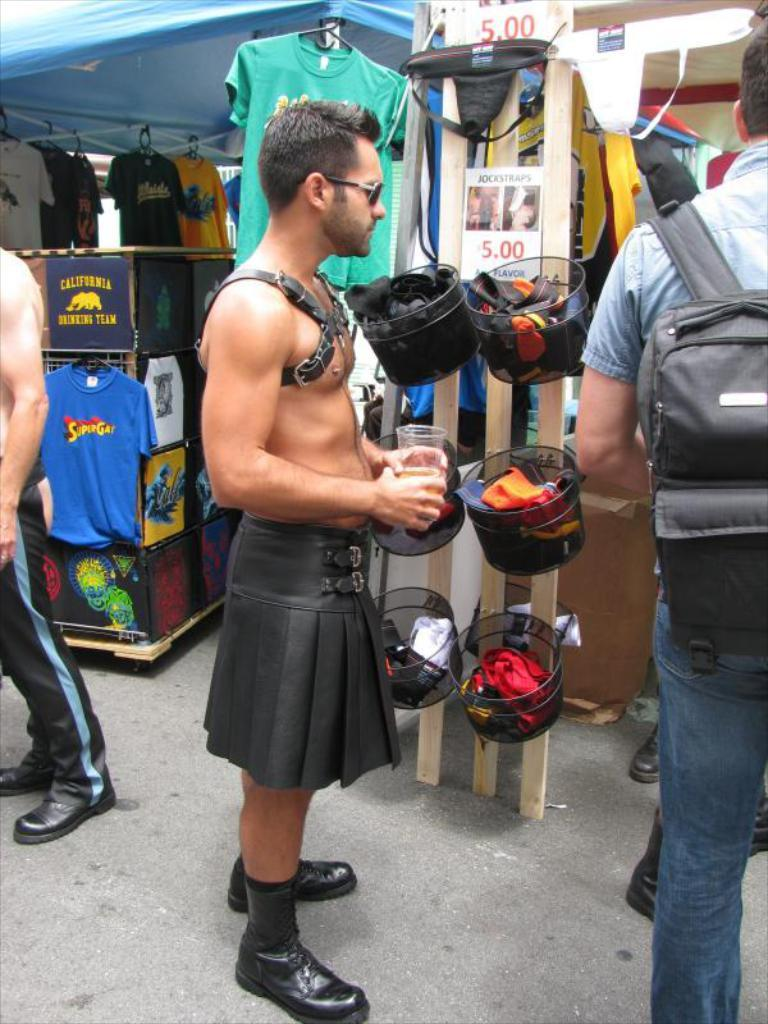What is happening in the image? There are people standing in the image. What is one person holding? One person is holding a glass. What can be seen in the background of the image? There are clothes and tents visible in the background. What airport is visible in the background of the image? There is no airport visible in the background of the image. What type of writing can be seen on the clothes in the background? There is no writing visible on the clothes in the background. 